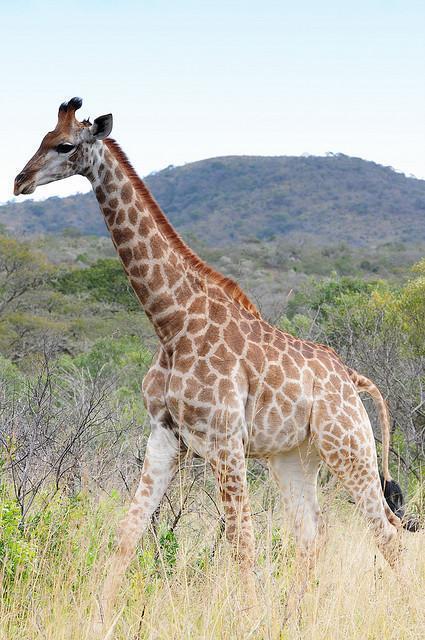How many hands does the clock have?
Give a very brief answer. 0. 